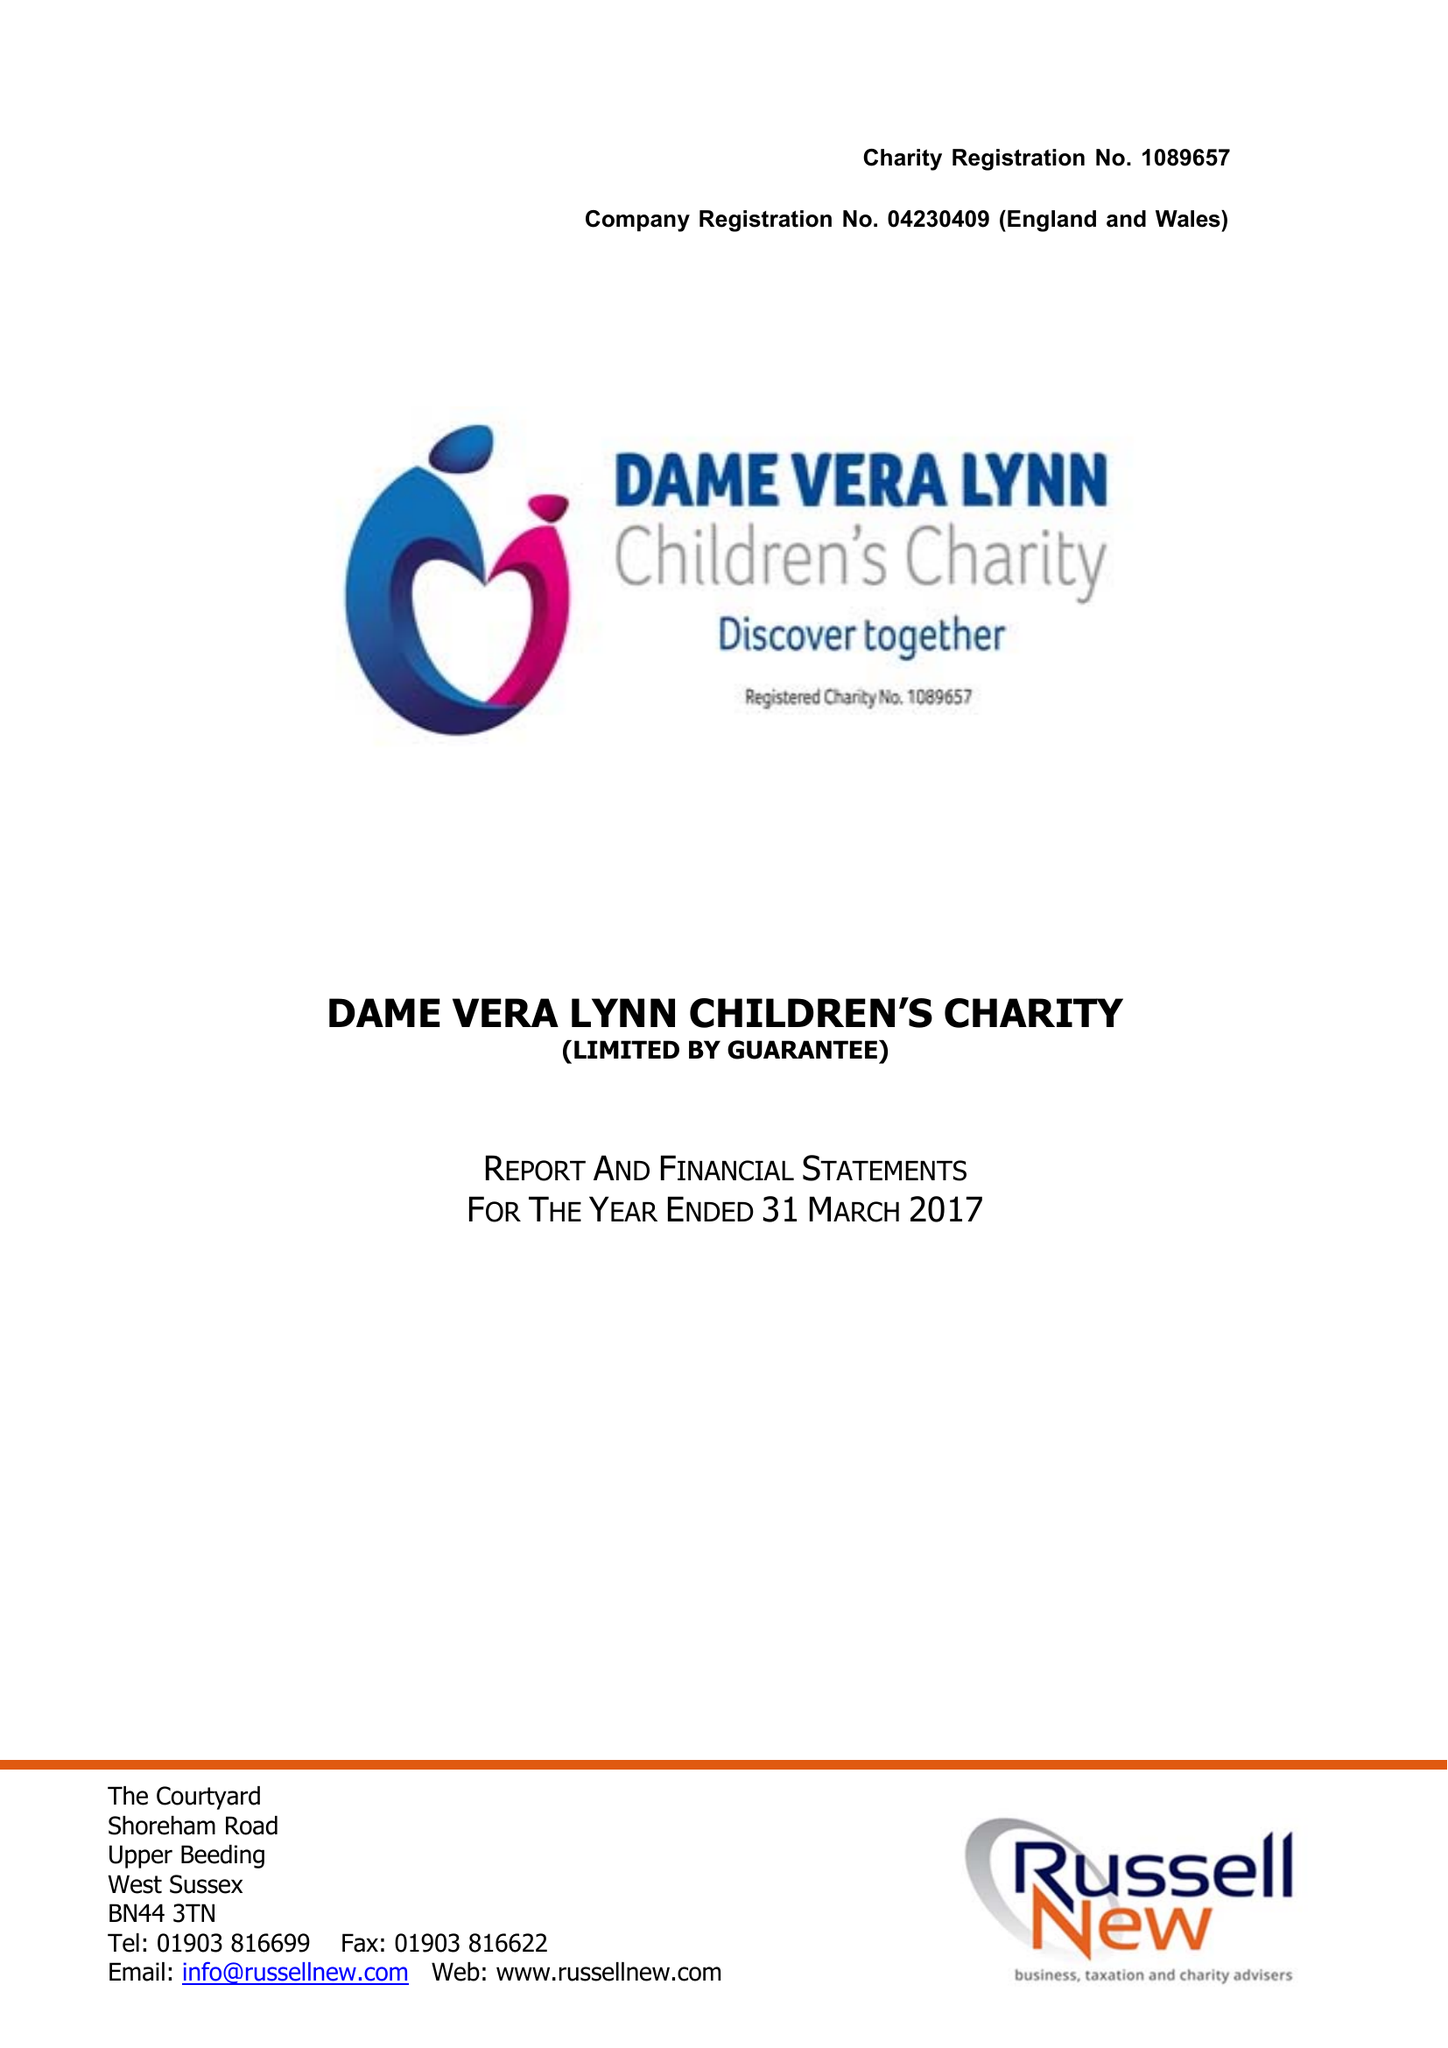What is the value for the charity_name?
Answer the question using a single word or phrase. Dame Vera Lynn Children's Charity 